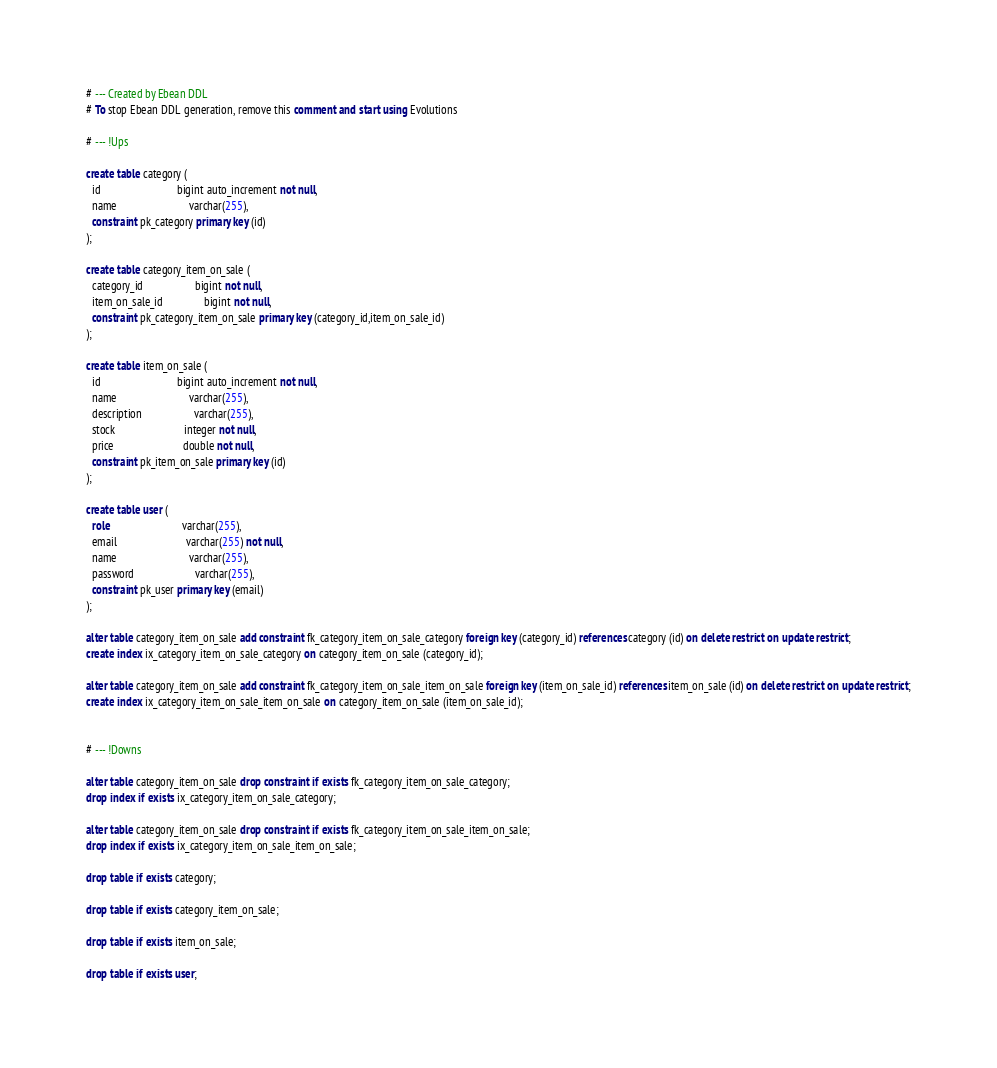<code> <loc_0><loc_0><loc_500><loc_500><_SQL_># --- Created by Ebean DDL
# To stop Ebean DDL generation, remove this comment and start using Evolutions

# --- !Ups

create table category (
  id                            bigint auto_increment not null,
  name                          varchar(255),
  constraint pk_category primary key (id)
);

create table category_item_on_sale (
  category_id                   bigint not null,
  item_on_sale_id               bigint not null,
  constraint pk_category_item_on_sale primary key (category_id,item_on_sale_id)
);

create table item_on_sale (
  id                            bigint auto_increment not null,
  name                          varchar(255),
  description                   varchar(255),
  stock                         integer not null,
  price                         double not null,
  constraint pk_item_on_sale primary key (id)
);

create table user (
  role                          varchar(255),
  email                         varchar(255) not null,
  name                          varchar(255),
  password                      varchar(255),
  constraint pk_user primary key (email)
);

alter table category_item_on_sale add constraint fk_category_item_on_sale_category foreign key (category_id) references category (id) on delete restrict on update restrict;
create index ix_category_item_on_sale_category on category_item_on_sale (category_id);

alter table category_item_on_sale add constraint fk_category_item_on_sale_item_on_sale foreign key (item_on_sale_id) references item_on_sale (id) on delete restrict on update restrict;
create index ix_category_item_on_sale_item_on_sale on category_item_on_sale (item_on_sale_id);


# --- !Downs

alter table category_item_on_sale drop constraint if exists fk_category_item_on_sale_category;
drop index if exists ix_category_item_on_sale_category;

alter table category_item_on_sale drop constraint if exists fk_category_item_on_sale_item_on_sale;
drop index if exists ix_category_item_on_sale_item_on_sale;

drop table if exists category;

drop table if exists category_item_on_sale;

drop table if exists item_on_sale;

drop table if exists user;

</code> 